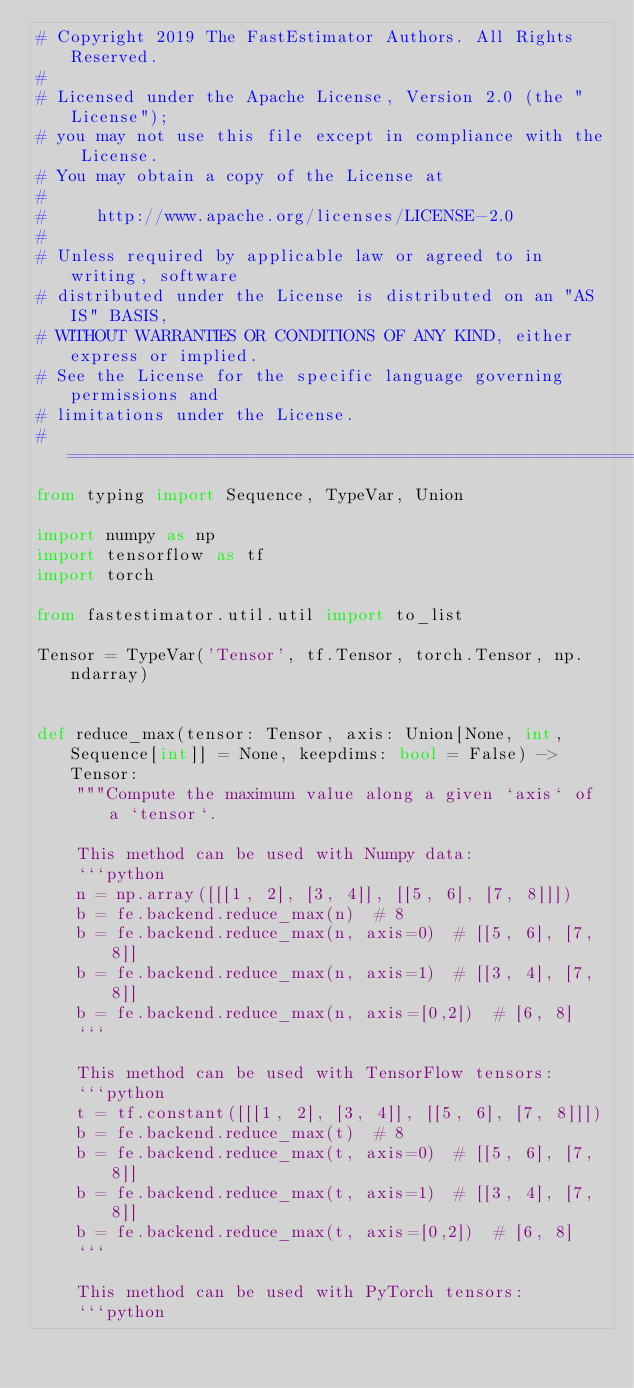Convert code to text. <code><loc_0><loc_0><loc_500><loc_500><_Python_># Copyright 2019 The FastEstimator Authors. All Rights Reserved.
#
# Licensed under the Apache License, Version 2.0 (the "License");
# you may not use this file except in compliance with the License.
# You may obtain a copy of the License at
#
#     http://www.apache.org/licenses/LICENSE-2.0
#
# Unless required by applicable law or agreed to in writing, software
# distributed under the License is distributed on an "AS IS" BASIS,
# WITHOUT WARRANTIES OR CONDITIONS OF ANY KIND, either express or implied.
# See the License for the specific language governing permissions and
# limitations under the License.
# ==============================================================================
from typing import Sequence, TypeVar, Union

import numpy as np
import tensorflow as tf
import torch

from fastestimator.util.util import to_list

Tensor = TypeVar('Tensor', tf.Tensor, torch.Tensor, np.ndarray)


def reduce_max(tensor: Tensor, axis: Union[None, int, Sequence[int]] = None, keepdims: bool = False) -> Tensor:
    """Compute the maximum value along a given `axis` of a `tensor`.

    This method can be used with Numpy data:
    ```python
    n = np.array([[[1, 2], [3, 4]], [[5, 6], [7, 8]]])
    b = fe.backend.reduce_max(n)  # 8
    b = fe.backend.reduce_max(n, axis=0)  # [[5, 6], [7, 8]]
    b = fe.backend.reduce_max(n, axis=1)  # [[3, 4], [7, 8]]
    b = fe.backend.reduce_max(n, axis=[0,2])  # [6, 8]
    ```

    This method can be used with TensorFlow tensors:
    ```python
    t = tf.constant([[[1, 2], [3, 4]], [[5, 6], [7, 8]]])
    b = fe.backend.reduce_max(t)  # 8
    b = fe.backend.reduce_max(t, axis=0)  # [[5, 6], [7, 8]]
    b = fe.backend.reduce_max(t, axis=1)  # [[3, 4], [7, 8]]
    b = fe.backend.reduce_max(t, axis=[0,2])  # [6, 8]
    ```

    This method can be used with PyTorch tensors:
    ```python</code> 